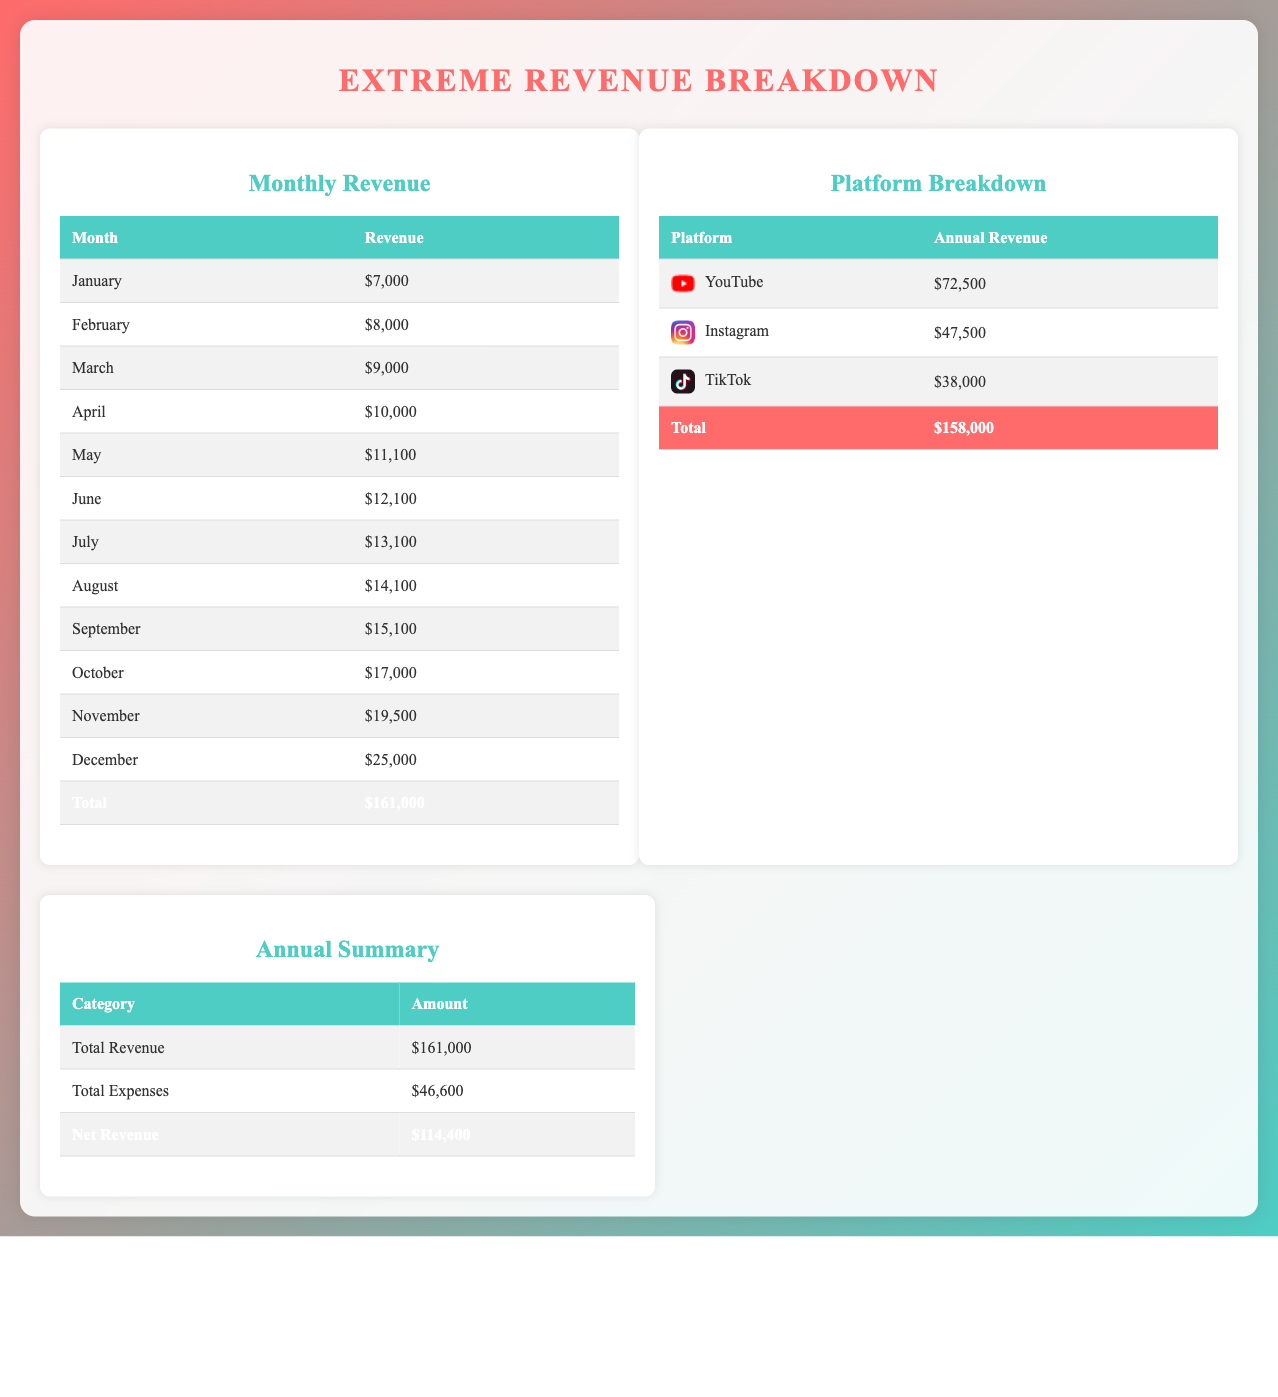what is the total revenue? The total revenue is listed in the Annual Summary section as $161,000.
Answer: $161,000 what were the total expenses? The total expenses are shown in the Annual Summary section as $46,600.
Answer: $46,600 which month had the highest revenue? The month with the highest revenue listed in the Monthly Revenue table is December with $25,000.
Answer: December what is the annual revenue from YouTube? The annual revenue from YouTube is detailed in the Platform Breakdown section as $72,500.
Answer: $72,500 how much revenue did Instagram generate? The revenue generated by Instagram is stated in the Platform Breakdown as $47,500.
Answer: $47,500 what is the net revenue? The net revenue is the difference between total revenue and total expenses, which is $114,400.
Answer: $114,400 which social media platform had the lowest revenue? The platform with the lowest revenue is TikTok, which earned $38,000 as stated in the Platform Breakdown.
Answer: TikTok how much revenue was earned in July? The revenue earned in July is recorded as $13,100 in the Monthly Revenue table.
Answer: $13,100 how much total revenue does the document attribute to Instagram and TikTok combined? The combined revenue of Instagram ($47,500) and TikTok ($38,000) amounts to $85,500.
Answer: $85,500 